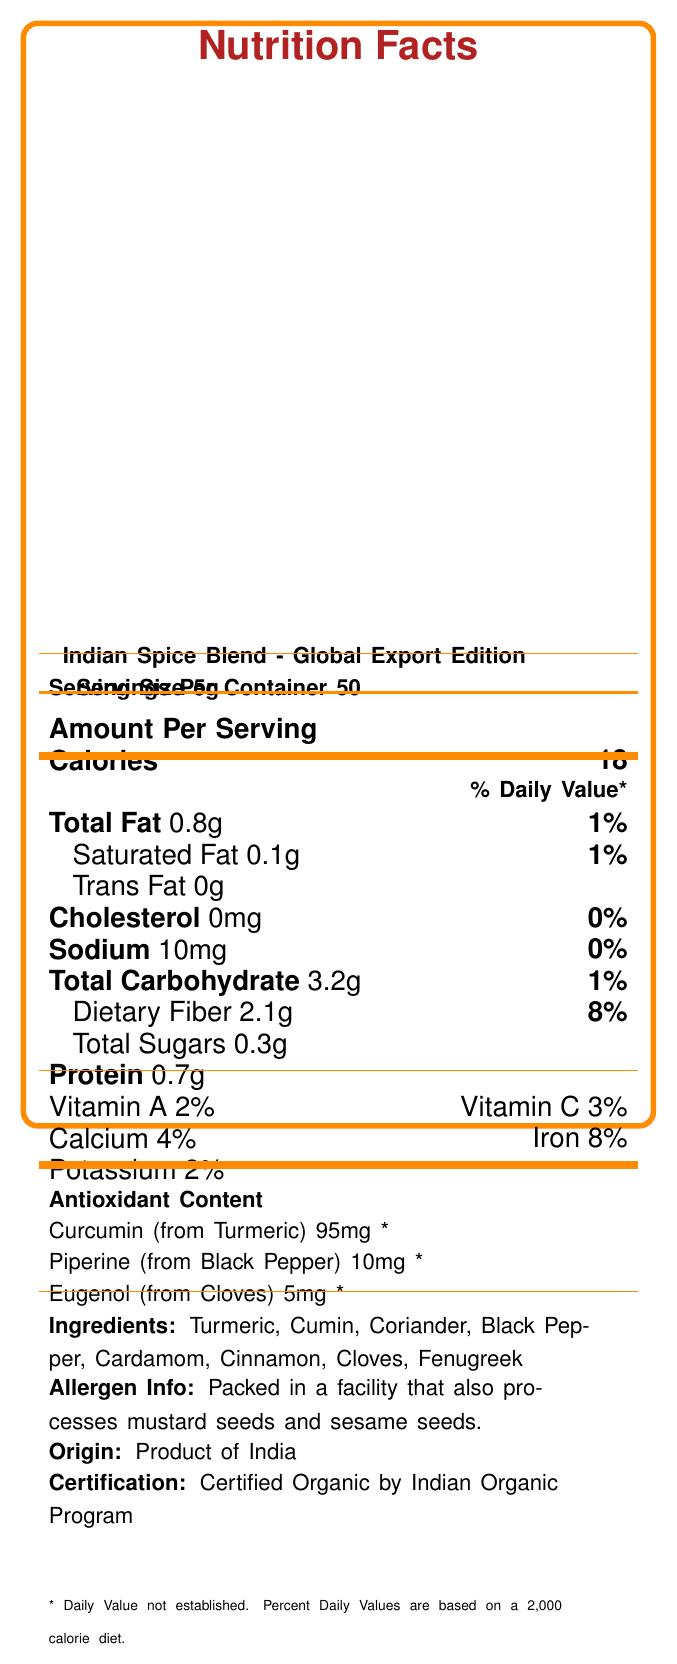what is the serving size? The document specifies that the serving size is 5g in the section detailing the amount per serving.
Answer: 5g how many servings are in one container? The document states that there are 50 servings per container in the nutrition facts.
Answer: 50 what is the total fat content per serving? The nutrition facts label lists the total fat content as 0.8g per serving.
Answer: 0.8g which antioxidant is present in the highest amount? The antioxidant content section shows that Curcumin (from Turmeric) is present in the highest amount, with 95mg per serving.
Answer: Curcumin (from Turmeric) what is the daily value percentage for dietary fiber? The document lists the daily value percentage for dietary fiber as 8%.
Answer: 8% what is the main export market for this spice blend? A. Germany B. United Kingdom C. Canada D. Japan The trade info section indicates that the main export markets include the United Kingdom.
Answer: B. United Kingdom what is the calorie content per serving? A. 12 B. 15 C. 18 D. 20 The document states that the calorie content per serving is 18 in the amount per serving section.
Answer: C. 18 is the product certified organic? The document mentions that the product is certified organic by the Indian Organic Program.
Answer: Yes what are the health benefits claimed for this spice blend? The health claims section lists these specific benefits.
Answer: Rich in antioxidants that may help reduce inflammation, may support digestive health, contains compounds that may enhance nutrient absorption how much iron is in each serving? The document states that each serving contains 8% of the daily value for iron.
Answer: 8% what are the allergen warnings for this product? The allergen info section provides this information.
Answer: Packed in a facility that also processes mustard seeds and sesame seeds can we determine the exact daily value for Piperine based on the document? The document states the daily value for Piperine is not established, indicated by an asterisk (*).
Answer: Not enough information summarize the key nutritional facts and additional information provided about the Indian Spice Blend - Global Export Edition. The document includes details about the nutritional content, antioxidants, ingredients, allergen warnings, origin, certification, export markets, and health claims for the Indian Spice Blend.
Answer: The Indian Spice Blend - Global Export Edition provides 18 calories per 5g serving with minimal fat and carbohydrates. It contains dietary fiber, proteins, and essential vitamins and minerals like Vitamin A, Vitamin C, calcium, iron, and potassium. The blend is rich in antioxidants such as Curcumin, Piperine, and Eugenol. The product is certified organic and primarily exported to countries like the United States, United Kingdom, and Canada. Additionally, it is packed in a facility that processes mustard and sesame seeds, and it claims to offer health benefits such as anti-inflammatory properties, digestive support, and enhanced nutrient absorption. what is the total carbohydrate content per serving? The document states that the total carbohydrate content per serving is 3.2g, according to the nutrition facts section.
Answer: 3.2g 